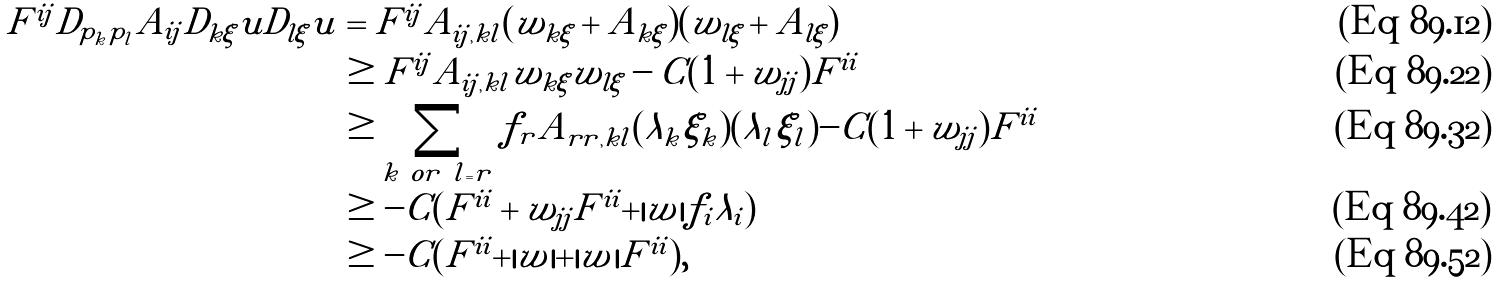Convert formula to latex. <formula><loc_0><loc_0><loc_500><loc_500>F ^ { i j } D _ { p _ { k } p _ { l } } A _ { i j } D _ { k \xi } u D _ { l \xi } u & = F ^ { i j } A _ { i j , k l } ( w _ { k \xi } + A _ { k \xi } ) ( w _ { l \xi } + A _ { l \xi } ) \\ & \geq F ^ { i j } A _ { i j , k l } w _ { k \xi } w _ { l \xi } - C ( 1 + w _ { j j } ) F ^ { i i } \\ & \geq \sum _ { k \ o r \ l = r } f _ { r } A _ { r r , k l } ( \lambda _ { k } \xi _ { k } ) ( \lambda _ { l } \xi _ { l } ) - C ( 1 + w _ { j j } ) F ^ { i i } \\ & \geq - C ( F ^ { i i } + w _ { j j } F ^ { i i } + | w | f _ { i } \lambda _ { i } ) \\ & \geq - C ( F ^ { i i } + | w | + | w | F ^ { i i } ) ,</formula> 